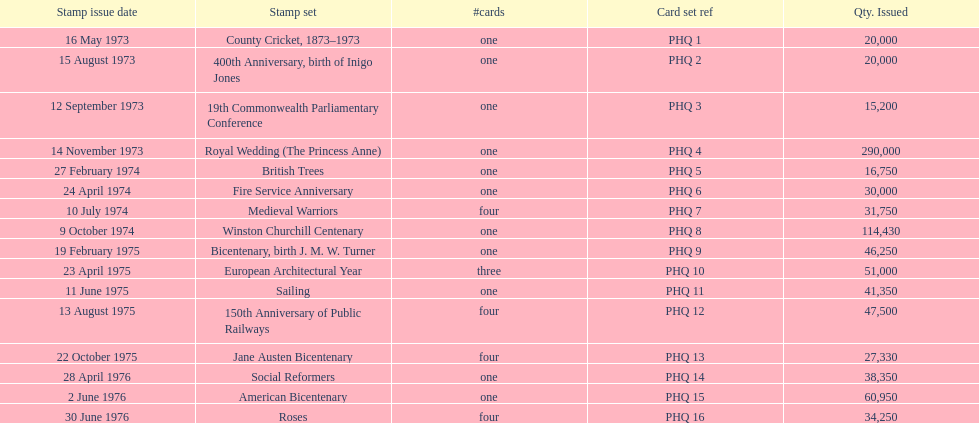Which year experienced the greatest number of stamp releases? 1973. 